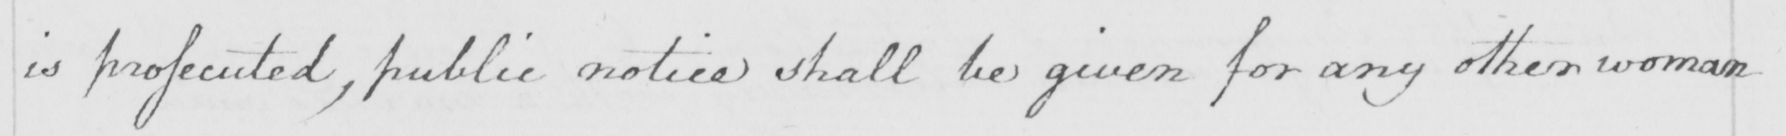Can you read and transcribe this handwriting? is prossecuted , public notice shall be given for any other woman 